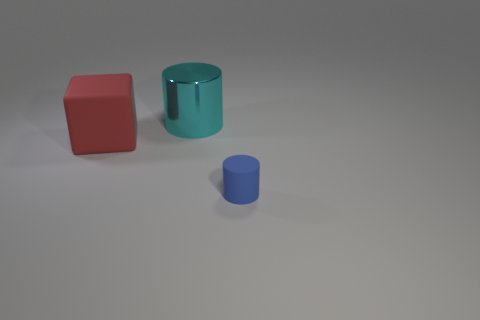What size is the other thing that is the same shape as the metal thing?
Give a very brief answer. Small. Is there any other thing that has the same size as the red thing?
Your answer should be very brief. Yes. There is a cube; are there any small blue rubber cylinders on the right side of it?
Keep it short and to the point. Yes. There is a rubber object behind the small matte object; is it the same color as the cylinder on the left side of the small blue matte thing?
Give a very brief answer. No. Are there any blue objects of the same shape as the large cyan object?
Your answer should be compact. Yes. How many other objects are the same color as the large cylinder?
Provide a short and direct response. 0. What color is the matte thing that is on the left side of the cylinder on the right side of the cylinder that is behind the tiny matte object?
Provide a short and direct response. Red. Are there the same number of cyan things behind the cyan metallic object and tiny blue matte cylinders?
Make the answer very short. No. There is a thing that is in front of the red object; is it the same size as the big cyan shiny object?
Offer a very short reply. No. What number of cyan matte cylinders are there?
Your answer should be very brief. 0. 